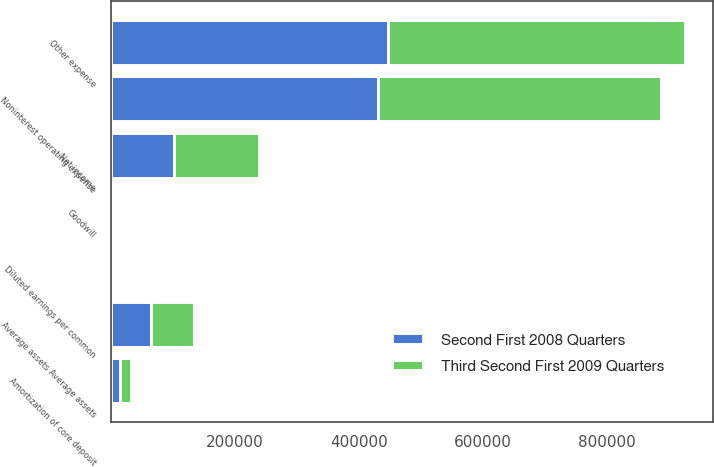Convert chart. <chart><loc_0><loc_0><loc_500><loc_500><stacked_bar_chart><ecel><fcel>Net income<fcel>Amortization of core deposit<fcel>Diluted earnings per common<fcel>Other expense<fcel>Noninterest operating expense<fcel>Average assets Average assets<fcel>Goodwill<nl><fcel>Third Second First 2009 Quarters<fcel>136818<fcel>16730<fcel>1.04<fcel>478451<fcel>455457<fcel>68919<fcel>3525<nl><fcel>Second First 2008 Quarters<fcel>102241<fcel>15708<fcel>0.92<fcel>446819<fcel>431111<fcel>64942<fcel>3192<nl></chart> 